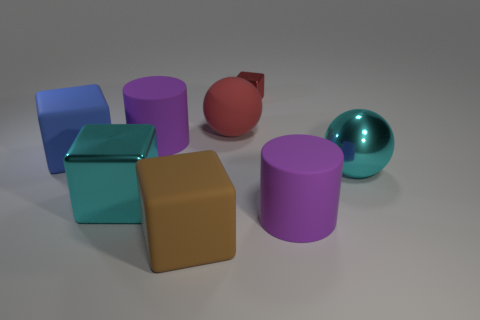Subtract all blue blocks. How many blocks are left? 3 Subtract all blue cubes. How many cubes are left? 3 Subtract all cylinders. How many objects are left? 6 Add 1 blue rubber things. How many objects exist? 9 Subtract 0 yellow balls. How many objects are left? 8 Subtract 1 cylinders. How many cylinders are left? 1 Subtract all cyan spheres. Subtract all blue cylinders. How many spheres are left? 1 Subtract all brown cylinders. How many blue blocks are left? 1 Subtract all matte blocks. Subtract all brown things. How many objects are left? 5 Add 1 large brown rubber blocks. How many large brown rubber blocks are left? 2 